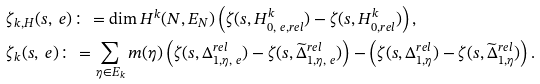<formula> <loc_0><loc_0><loc_500><loc_500>& \zeta _ { k , H } ( s , \ e ) \colon = \dim H ^ { k } ( N , E _ { N } ) \left ( \zeta ( s , H ^ { k } _ { 0 , \ e , r e l } ) - \zeta ( s , H ^ { k } _ { 0 , r e l } ) \right ) , \\ & \zeta _ { k } ( s , \ e ) \colon = \sum _ { \eta \in E _ { k } } m ( \eta ) \left ( \zeta ( s , \Delta _ { 1 , \eta , \ e } ^ { r e l } ) - \zeta ( s , \widetilde { \Delta } _ { 1 , \eta , \ e } ^ { r e l } ) \right ) - \left ( \zeta ( s , \Delta _ { 1 , \eta } ^ { r e l } ) - \zeta ( s , \widetilde { \Delta } _ { 1 , \eta } ^ { r e l } ) \right ) .</formula> 